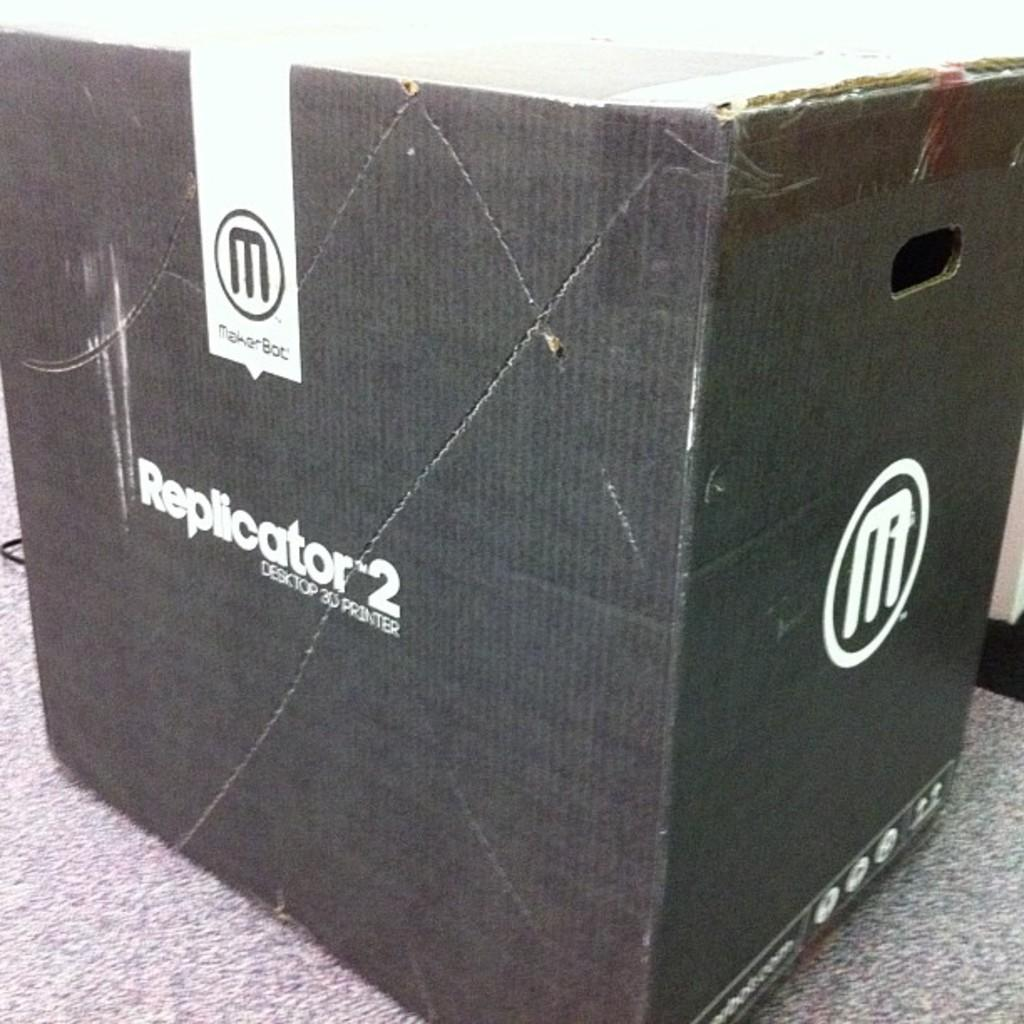What is located in the center of the image? There is a cardboard box in the center of the image. Can you describe the position of the cardboard box in the image? The cardboard box is placed on the floor. What type of agreement is being reached by the cardboard box and the tongue in the image? There is no tongue or agreement present in the image; it only features a cardboard box placed on the floor. 